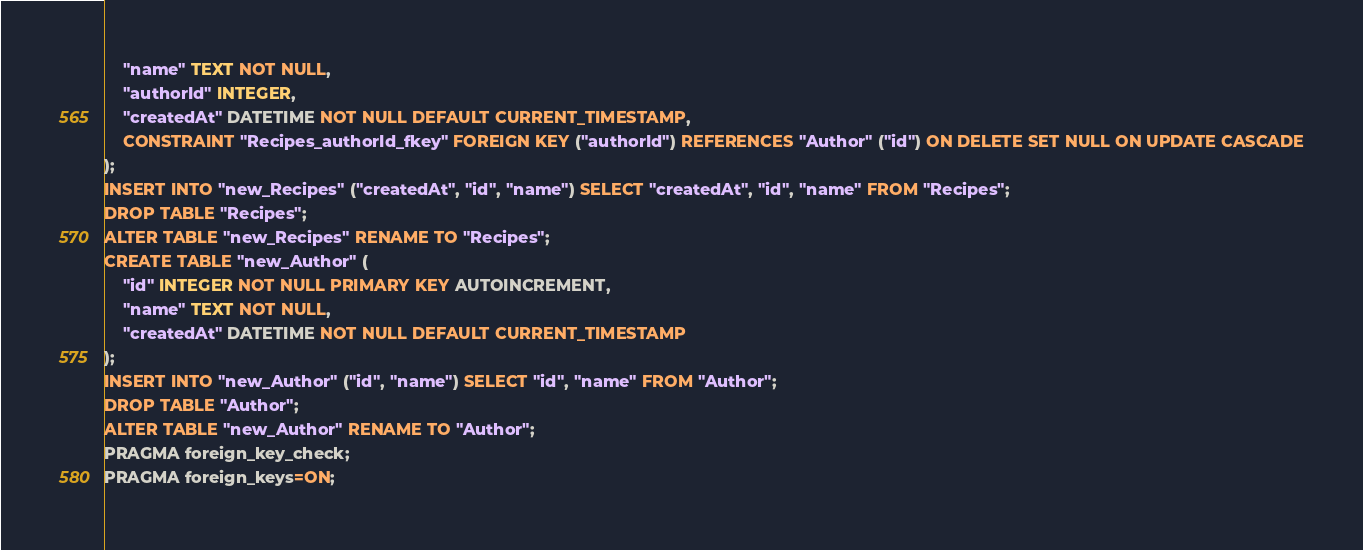<code> <loc_0><loc_0><loc_500><loc_500><_SQL_>    "name" TEXT NOT NULL,
    "authorId" INTEGER,
    "createdAt" DATETIME NOT NULL DEFAULT CURRENT_TIMESTAMP,
    CONSTRAINT "Recipes_authorId_fkey" FOREIGN KEY ("authorId") REFERENCES "Author" ("id") ON DELETE SET NULL ON UPDATE CASCADE
);
INSERT INTO "new_Recipes" ("createdAt", "id", "name") SELECT "createdAt", "id", "name" FROM "Recipes";
DROP TABLE "Recipes";
ALTER TABLE "new_Recipes" RENAME TO "Recipes";
CREATE TABLE "new_Author" (
    "id" INTEGER NOT NULL PRIMARY KEY AUTOINCREMENT,
    "name" TEXT NOT NULL,
    "createdAt" DATETIME NOT NULL DEFAULT CURRENT_TIMESTAMP
);
INSERT INTO "new_Author" ("id", "name") SELECT "id", "name" FROM "Author";
DROP TABLE "Author";
ALTER TABLE "new_Author" RENAME TO "Author";
PRAGMA foreign_key_check;
PRAGMA foreign_keys=ON;
</code> 